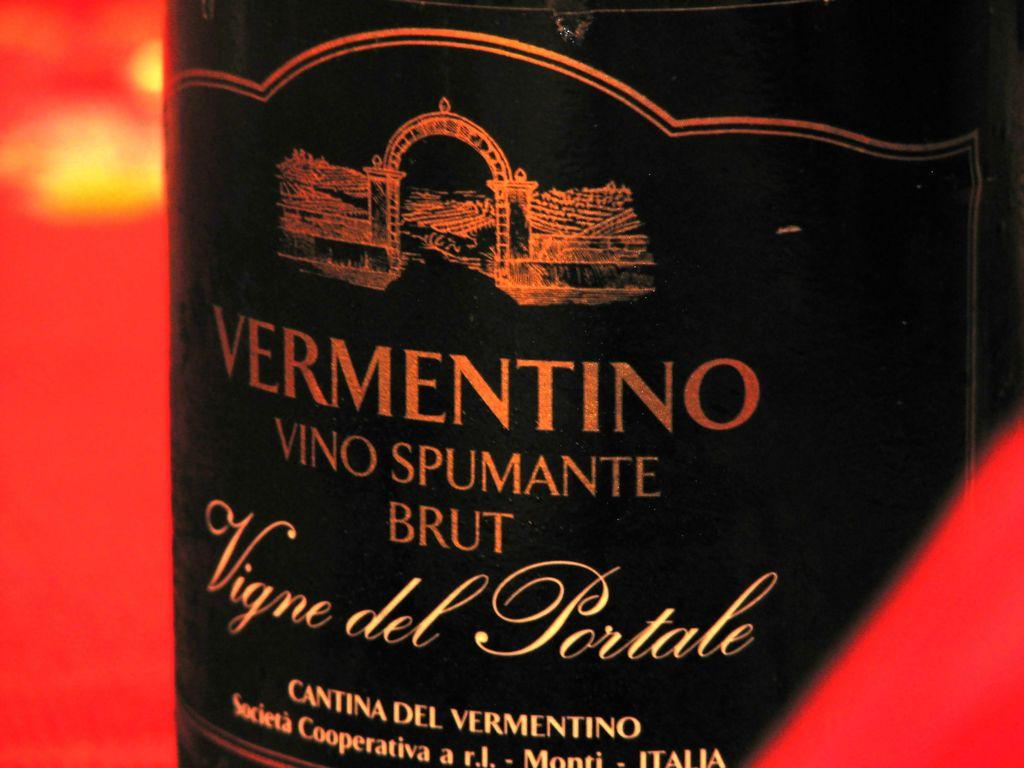<image>
Create a compact narrative representing the image presented. A bottle of Vermentino Vino Spumante Brut against a red backdrop. 